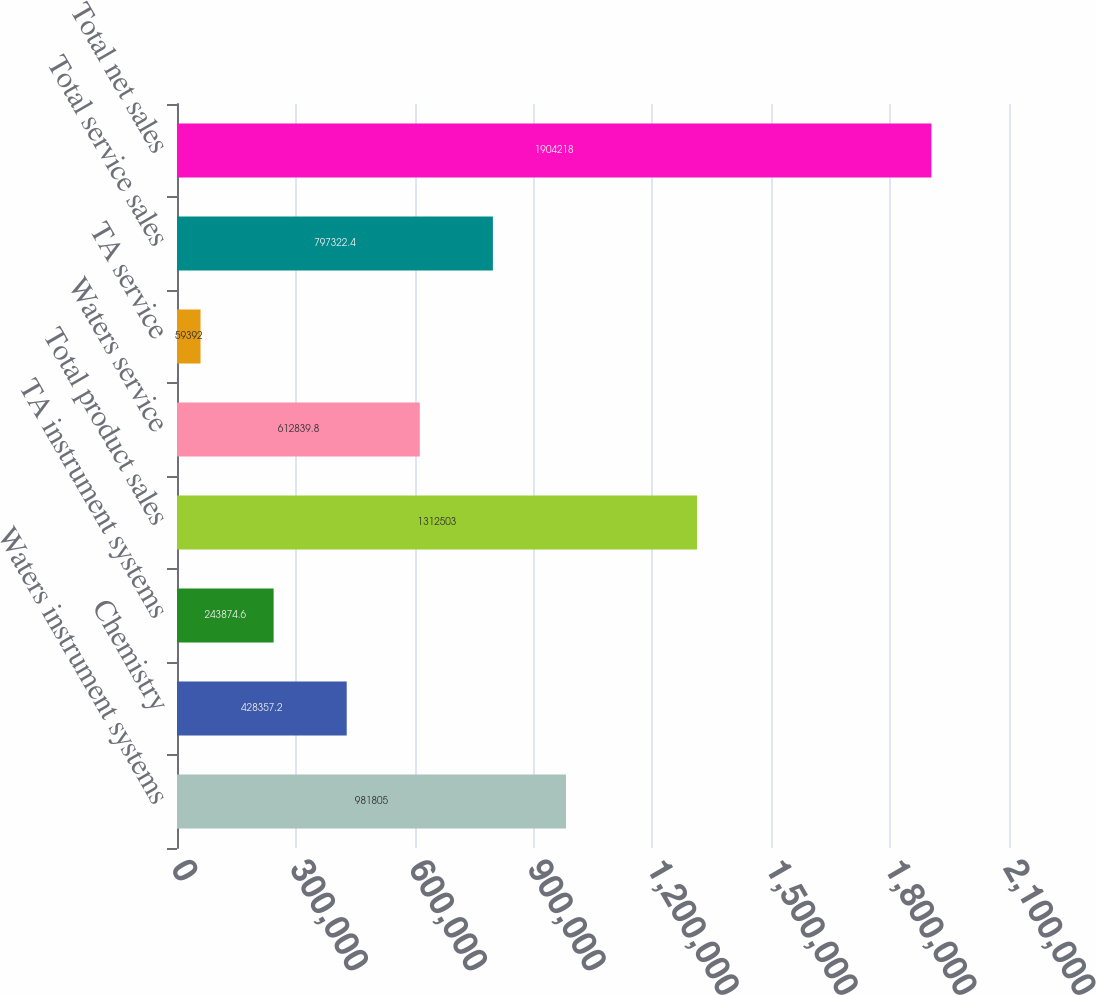<chart> <loc_0><loc_0><loc_500><loc_500><bar_chart><fcel>Waters instrument systems<fcel>Chemistry<fcel>TA instrument systems<fcel>Total product sales<fcel>Waters service<fcel>TA service<fcel>Total service sales<fcel>Total net sales<nl><fcel>981805<fcel>428357<fcel>243875<fcel>1.3125e+06<fcel>612840<fcel>59392<fcel>797322<fcel>1.90422e+06<nl></chart> 